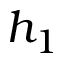Convert formula to latex. <formula><loc_0><loc_0><loc_500><loc_500>h _ { 1 }</formula> 